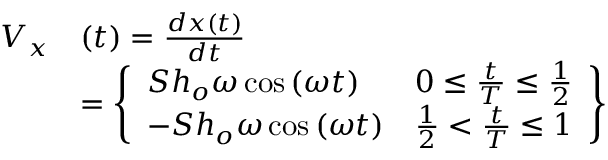Convert formula to latex. <formula><loc_0><loc_0><loc_500><loc_500>\begin{array} { r l } { V _ { x } } & { ( t ) = \frac { d x ( t ) } { d t } } \\ & { = \left \{ \begin{array} { l l } { S h _ { o } \omega \cos \left ( \omega t \right ) } & { 0 \leq \frac { t } { T } \leq \frac { 1 } { 2 } } \\ { - S h _ { o } \omega \cos \left ( \omega t \right ) } & { \frac { 1 } { 2 } < \frac { t } { T } \leq 1 } \end{array} \right \} } \end{array}</formula> 